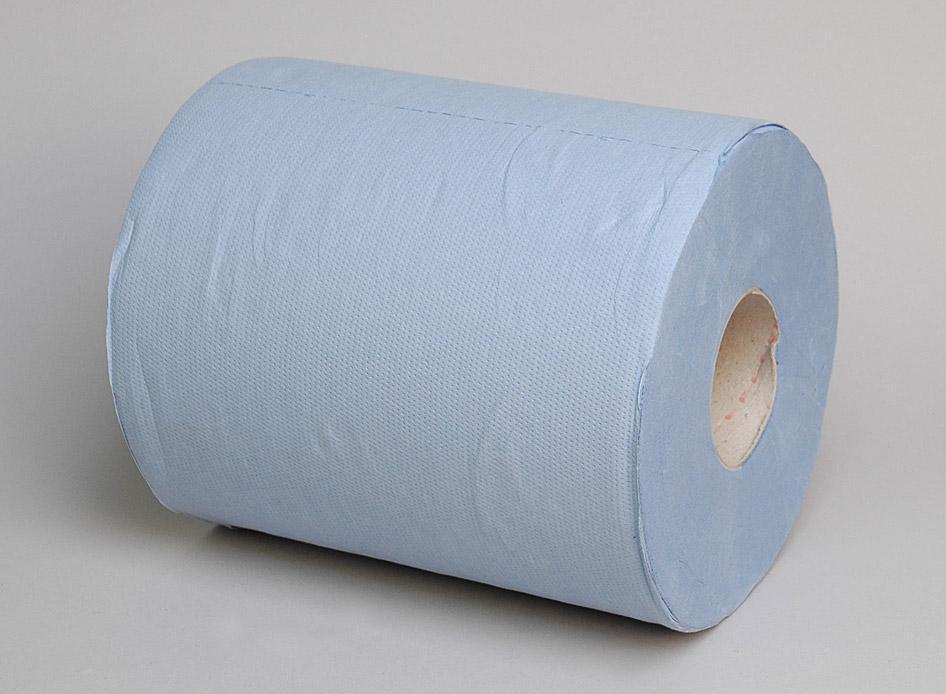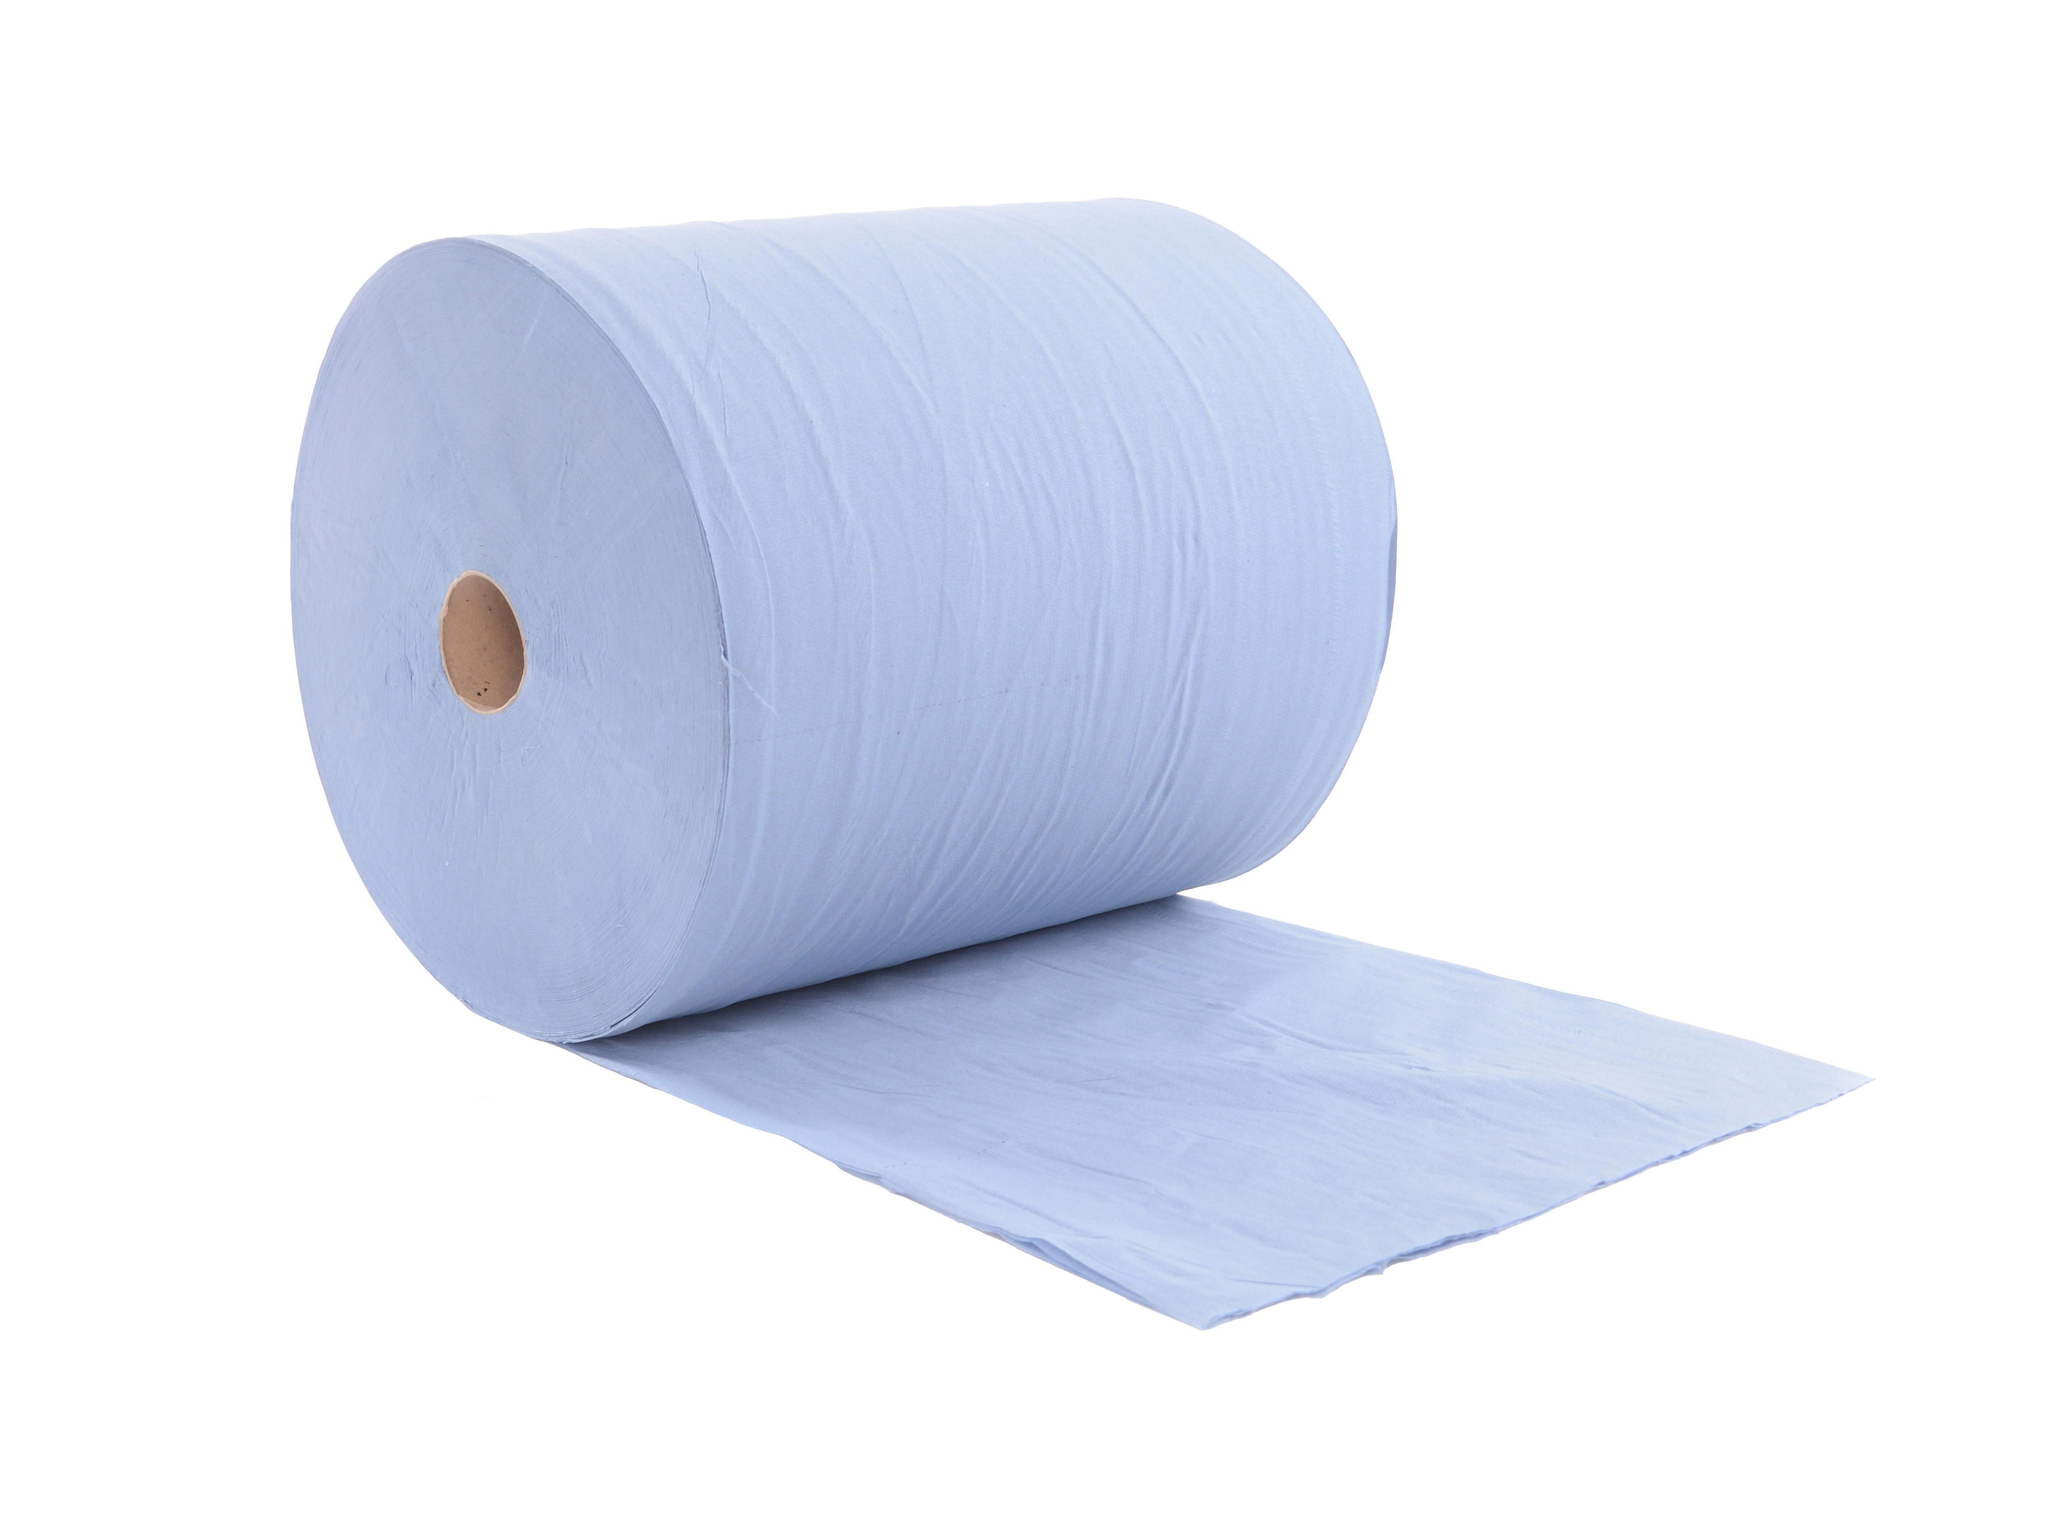The first image is the image on the left, the second image is the image on the right. Considering the images on both sides, is "At least 1 roll is standing vertically." valid? Answer yes or no. No. 